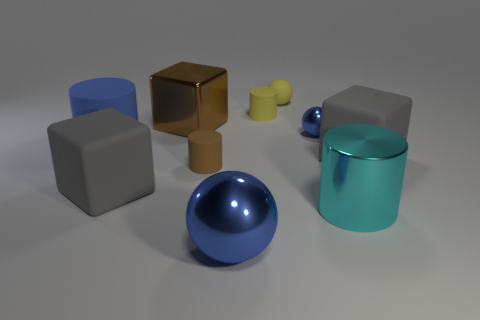Subtract all small spheres. How many spheres are left? 1 Subtract 1 balls. How many balls are left? 2 Subtract all cyan cylinders. How many gray blocks are left? 2 Subtract all spheres. How many objects are left? 7 Add 8 yellow matte cylinders. How many yellow matte cylinders exist? 9 Subtract all yellow cylinders. How many cylinders are left? 3 Subtract 1 yellow spheres. How many objects are left? 9 Subtract all gray cubes. Subtract all green balls. How many cubes are left? 1 Subtract all blue objects. Subtract all big gray rubber blocks. How many objects are left? 5 Add 6 big cyan cylinders. How many big cyan cylinders are left? 7 